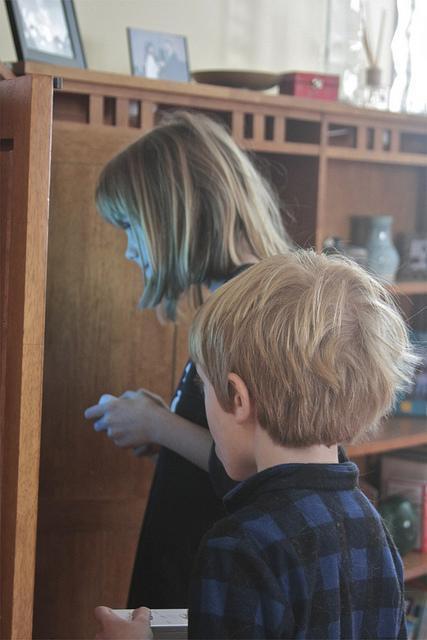How many people can be seen?
Give a very brief answer. 2. 